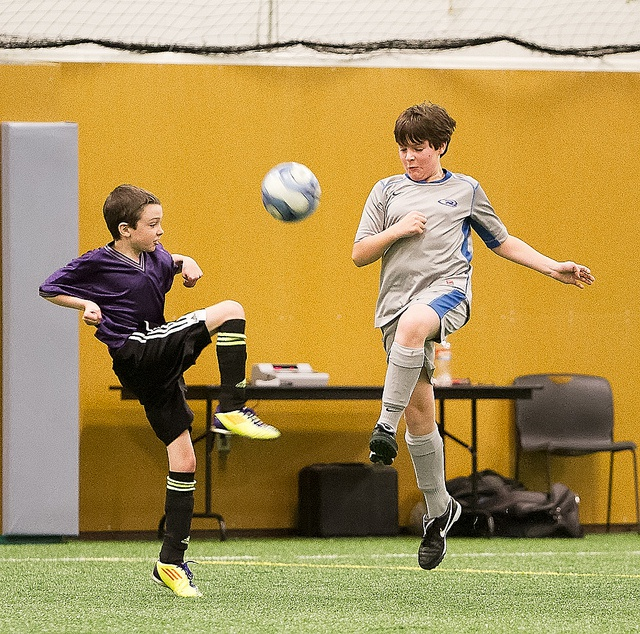Describe the objects in this image and their specific colors. I can see people in lightgray, darkgray, black, and tan tones, people in lightgray, black, ivory, khaki, and gray tones, chair in lightgray, gray, and black tones, backpack in lightgray, black, and gray tones, and suitcase in lightgray, black, and gray tones in this image. 